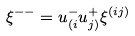<formula> <loc_0><loc_0><loc_500><loc_500>\xi ^ { - - } = u _ { ( i } ^ { - } u _ { j ) } ^ { + } \xi ^ { ( i j ) }</formula> 